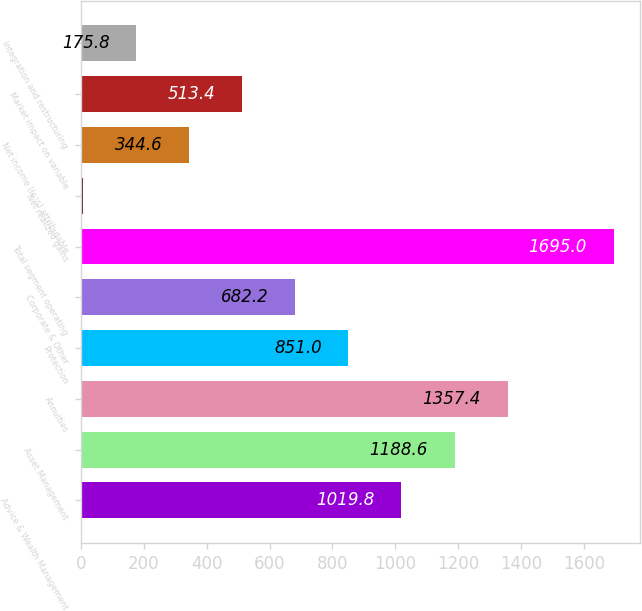<chart> <loc_0><loc_0><loc_500><loc_500><bar_chart><fcel>Advice & Wealth Management<fcel>Asset Management<fcel>Annuities<fcel>Protection<fcel>Corporate & Other<fcel>Total segment operating<fcel>Net realized gains<fcel>Net income (loss) attributable<fcel>Market impact on variable<fcel>Integration and restructuring<nl><fcel>1019.8<fcel>1188.6<fcel>1357.4<fcel>851<fcel>682.2<fcel>1695<fcel>7<fcel>344.6<fcel>513.4<fcel>175.8<nl></chart> 